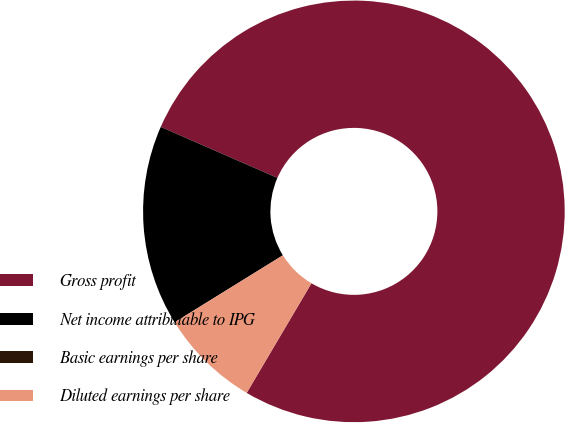Convert chart to OTSL. <chart><loc_0><loc_0><loc_500><loc_500><pie_chart><fcel>Gross profit<fcel>Net income attributable to IPG<fcel>Basic earnings per share<fcel>Diluted earnings per share<nl><fcel>76.92%<fcel>15.38%<fcel>0.0%<fcel>7.69%<nl></chart> 